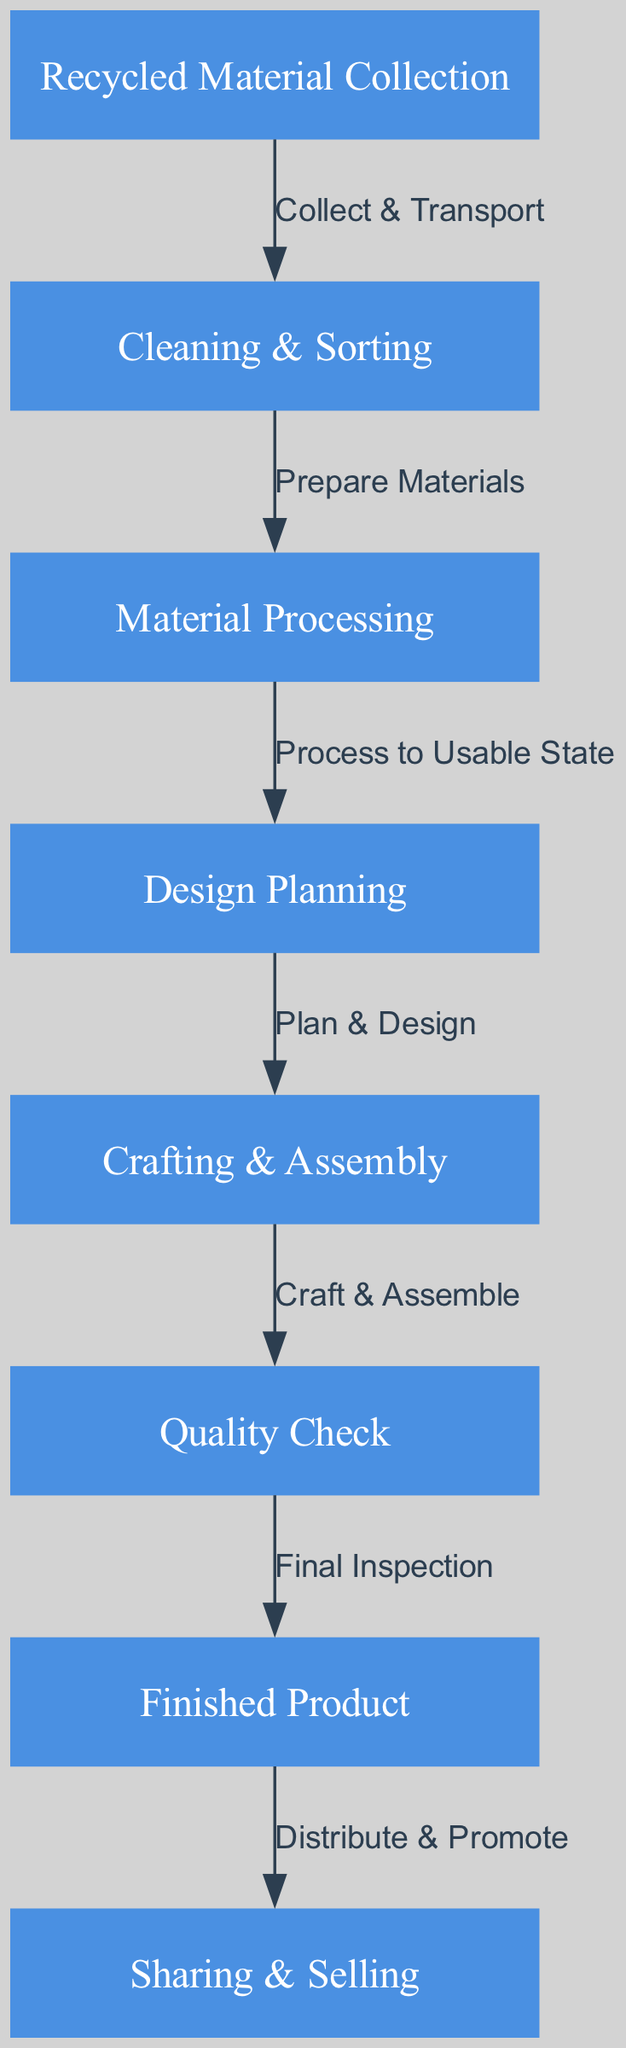What is the first step in the food chain? The first step is "Recycled Material Collection," which is the starting point of the sustainable craft project process according to the diagram.
Answer: Recycled Material Collection How many nodes are present in the diagram? The diagram contains a total of eight nodes, which represent various stages in the food chain.
Answer: Eight What label connects "Cleaning & Sorting" to "Material Processing"? The label connecting these two nodes is "Prepare Materials," indicating the process that occurs between cleaning and moving onto processing the materials.
Answer: Prepare Materials Which step follows "Crafting & Assembly"? The step that follows "Crafting & Assembly" is "Quality Check," indicating the next phase where the product is inspected for quality after assembly.
Answer: Quality Check What is the final product in this food chain? The final product in this food chain is labeled as "Finished Product," which represents the end result of all the preceding processes.
Answer: Finished Product What is the relationship between "Finished Product" and "Sharing & Selling"? The relationship is described by the label "Distribute & Promote," which explains the final action taken with the finished product.
Answer: Distribute & Promote How many edges connect the nodes in the diagram? There are a total of seven edges, linking the eight nodes through defined processes in the food chain.
Answer: Seven Which step directly precedes "Design Planning"? The step that directly precedes "Design Planning" is "Material Processing," as indicated by the flow of the food chain.
Answer: Material Processing What process occurs after "Quality Check"? The process that occurs after "Quality Check" is "Finished Product," which indicates the completion of the inspection step before distribution.
Answer: Finished Product 